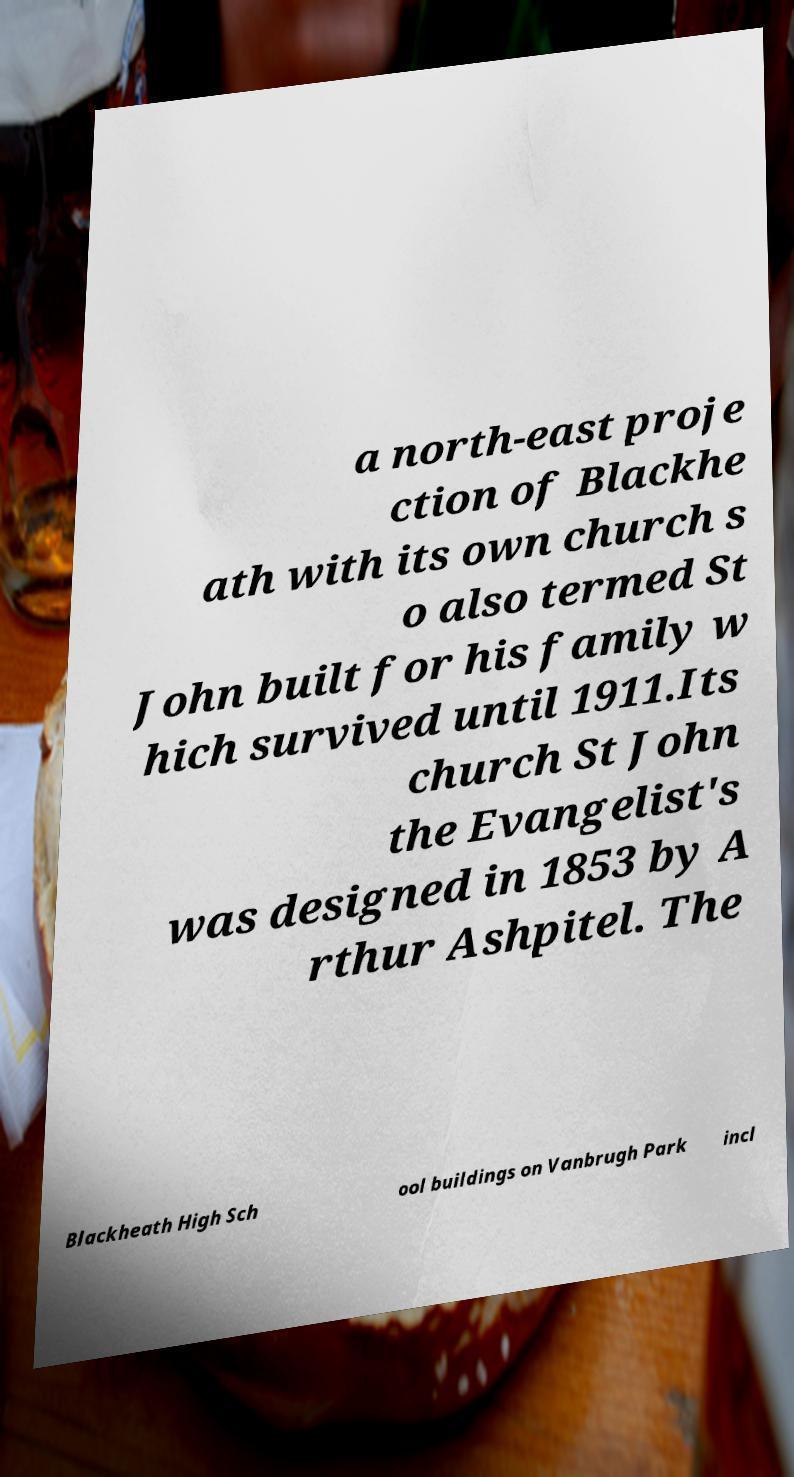Could you extract and type out the text from this image? a north-east proje ction of Blackhe ath with its own church s o also termed St John built for his family w hich survived until 1911.Its church St John the Evangelist's was designed in 1853 by A rthur Ashpitel. The Blackheath High Sch ool buildings on Vanbrugh Park incl 